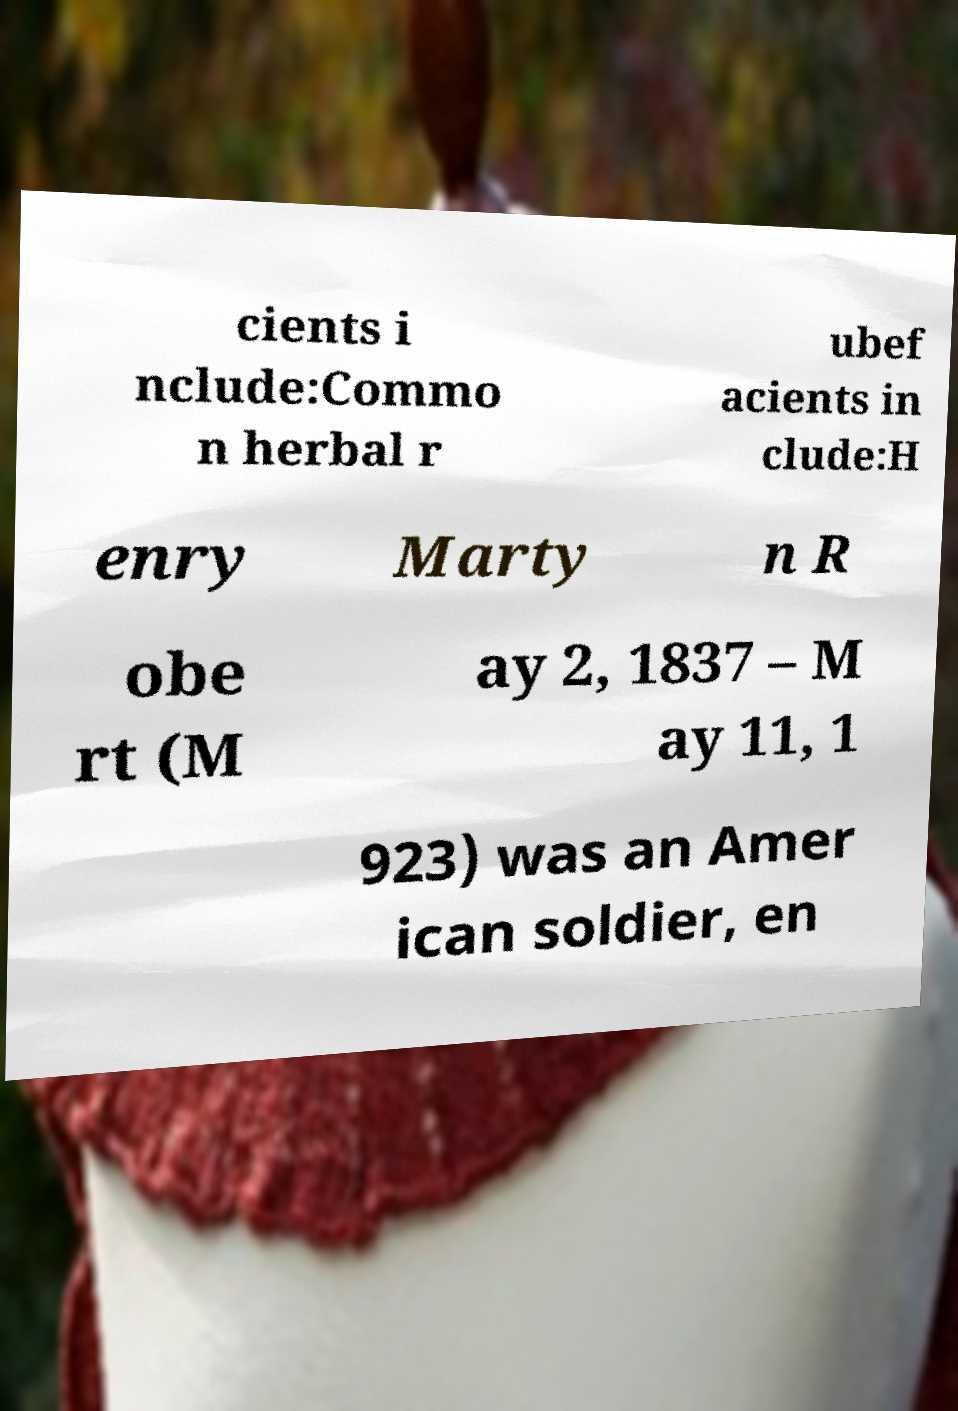Could you extract and type out the text from this image? cients i nclude:Commo n herbal r ubef acients in clude:H enry Marty n R obe rt (M ay 2, 1837 – M ay 11, 1 923) was an Amer ican soldier, en 